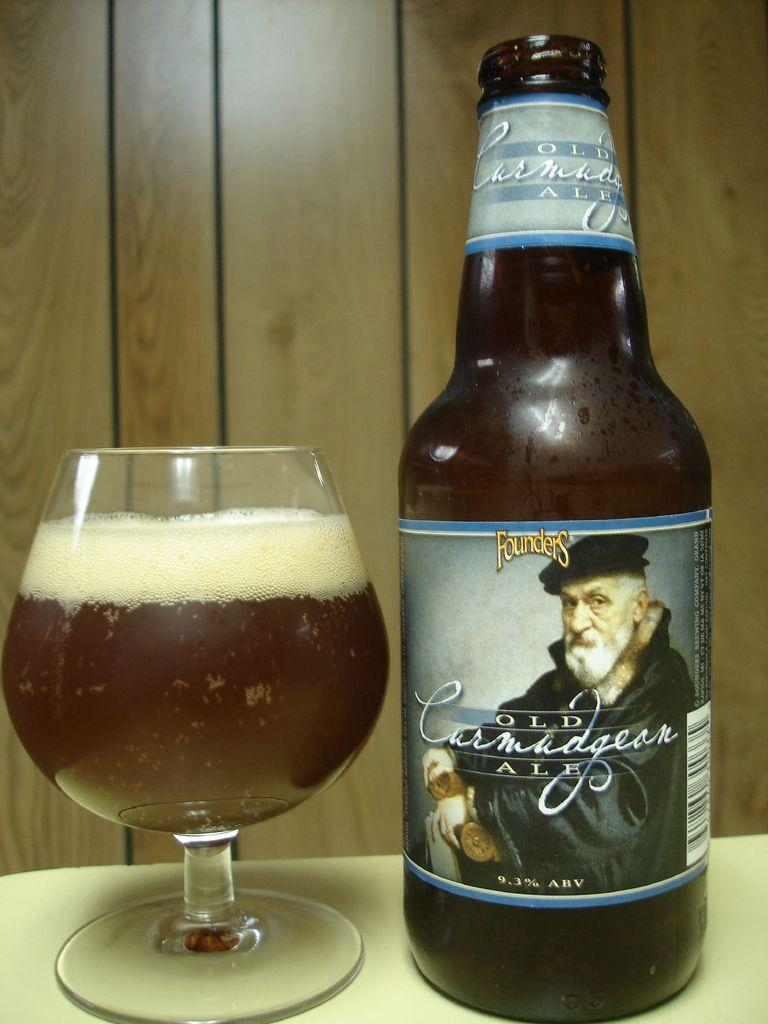What type of beverage container is present in the image? There is a beer bottle in the image. What other type of container for the same beverage can be seen? There is a beer glass in the image. Where are the beer bottle and glass located? Both the beer bottle and glass are on a table. What can be seen in the background of the image? There is a wooden wall in the background of the image. How many babies are crawling on the wooden wall in the image? There are no babies present in the image; it only features a beer bottle, a beer glass, and a wooden wall in the background. 